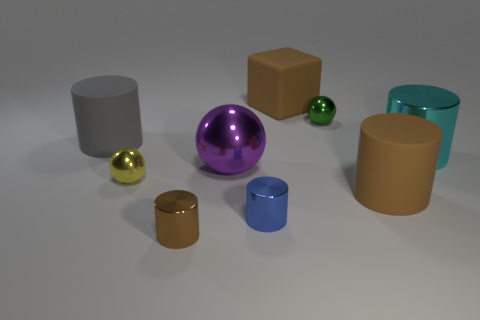Does the metallic cylinder that is in front of the small blue metal object have the same color as the matte cylinder that is on the right side of the green metal ball?
Make the answer very short. Yes. There is a small metallic object that is to the right of the small blue metal cylinder; what shape is it?
Offer a terse response. Sphere. Are there fewer large cyan shiny objects than tiny objects?
Offer a terse response. Yes. Are the ball behind the large purple ball and the blue cylinder made of the same material?
Provide a short and direct response. Yes. Are there any matte cylinders left of the large brown rubber cube?
Make the answer very short. Yes. The big rubber cylinder that is on the right side of the brown cylinder in front of the small metallic cylinder behind the tiny brown object is what color?
Give a very brief answer. Brown. What shape is the purple object that is the same size as the brown matte cylinder?
Provide a short and direct response. Sphere. Is the number of large purple metallic balls greater than the number of tiny balls?
Offer a very short reply. No. Is there a matte cylinder behind the large brown object that is in front of the large gray matte cylinder?
Keep it short and to the point. Yes. There is another tiny object that is the same shape as the small yellow thing; what is its color?
Give a very brief answer. Green. 